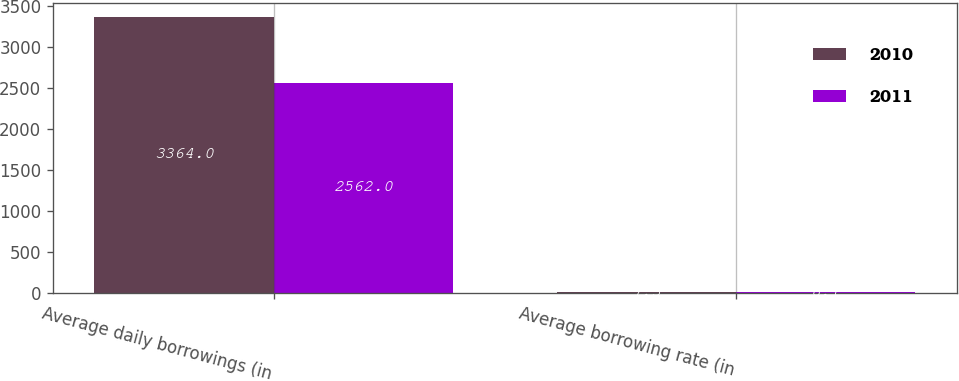Convert chart. <chart><loc_0><loc_0><loc_500><loc_500><stacked_bar_chart><ecel><fcel>Average daily borrowings (in<fcel>Average borrowing rate (in<nl><fcel>2010<fcel>3364<fcel>7.3<nl><fcel>2011<fcel>2562<fcel>8.1<nl></chart> 